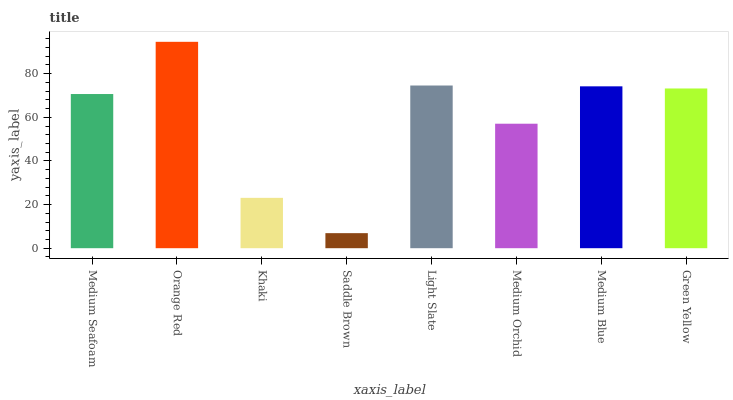Is Saddle Brown the minimum?
Answer yes or no. Yes. Is Orange Red the maximum?
Answer yes or no. Yes. Is Khaki the minimum?
Answer yes or no. No. Is Khaki the maximum?
Answer yes or no. No. Is Orange Red greater than Khaki?
Answer yes or no. Yes. Is Khaki less than Orange Red?
Answer yes or no. Yes. Is Khaki greater than Orange Red?
Answer yes or no. No. Is Orange Red less than Khaki?
Answer yes or no. No. Is Green Yellow the high median?
Answer yes or no. Yes. Is Medium Seafoam the low median?
Answer yes or no. Yes. Is Khaki the high median?
Answer yes or no. No. Is Green Yellow the low median?
Answer yes or no. No. 